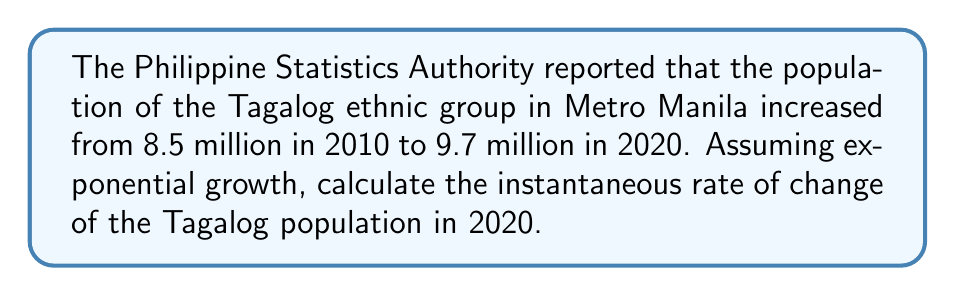Solve this math problem. To solve this problem, we'll use the exponential growth model and find the derivative at t = 10 (2020).

Step 1: Set up the exponential growth model
$$P(t) = P_0e^{rt}$$
where $P_0$ is the initial population, $r$ is the growth rate, and $t$ is time in years.

Step 2: Use the given data to find $r$
$$9.7 = 8.5e^{10r}$$

Step 3: Solve for $r$
$$\frac{9.7}{8.5} = e^{10r}$$
$$\ln(\frac{9.7}{8.5}) = 10r$$
$$r = \frac{1}{10}\ln(\frac{9.7}{8.5}) \approx 0.0133$$

Step 4: Write the population function
$$P(t) = 8.5e^{0.0133t}$$

Step 5: Find the derivative
$$\frac{dP}{dt} = 8.5 \cdot 0.0133 \cdot e^{0.0133t}$$

Step 6: Evaluate at t = 10 (2020)
$$\frac{dP}{dt}(10) = 8.5 \cdot 0.0133 \cdot e^{0.0133 \cdot 10}$$
$$= 8.5 \cdot 0.0133 \cdot e^{0.133}$$
$$\approx 0.129 \text{ million per year}$$
Answer: 0.129 million per year 